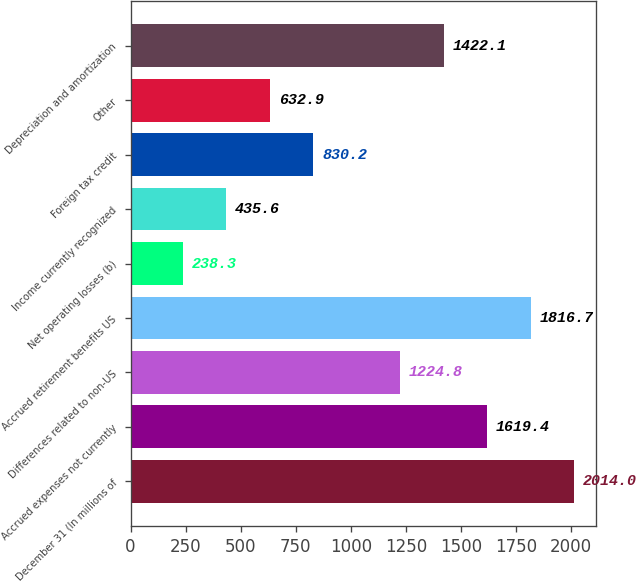<chart> <loc_0><loc_0><loc_500><loc_500><bar_chart><fcel>December 31 (In millions of<fcel>Accrued expenses not currently<fcel>Differences related to non-US<fcel>Accrued retirement benefits US<fcel>Net operating losses (b)<fcel>Income currently recognized<fcel>Foreign tax credit<fcel>Other<fcel>Depreciation and amortization<nl><fcel>2014<fcel>1619.4<fcel>1224.8<fcel>1816.7<fcel>238.3<fcel>435.6<fcel>830.2<fcel>632.9<fcel>1422.1<nl></chart> 